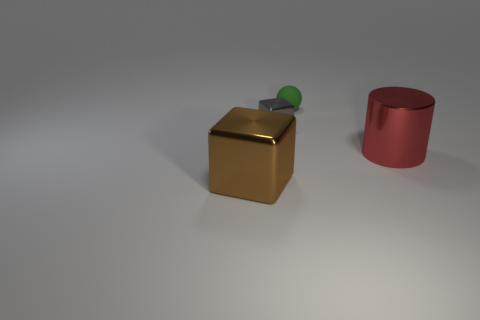Add 2 small red rubber things. How many objects exist? 6 Subtract all brown blocks. How many blocks are left? 1 Add 2 spheres. How many spheres are left? 3 Add 4 tiny gray shiny objects. How many tiny gray shiny objects exist? 5 Subtract 0 red balls. How many objects are left? 4 Subtract all balls. How many objects are left? 3 Subtract all green blocks. Subtract all blue cylinders. How many blocks are left? 2 Subtract all big cyan blocks. Subtract all large red metallic objects. How many objects are left? 3 